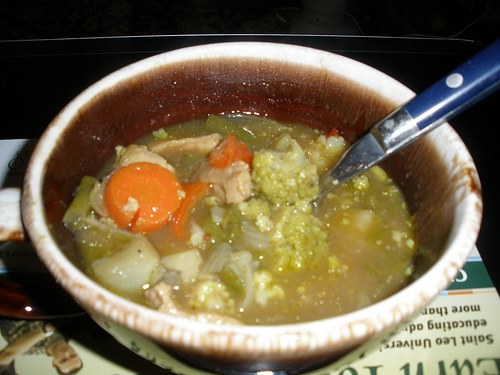Are there any large potatoes? No, there are no large potatoes visible in the image. 